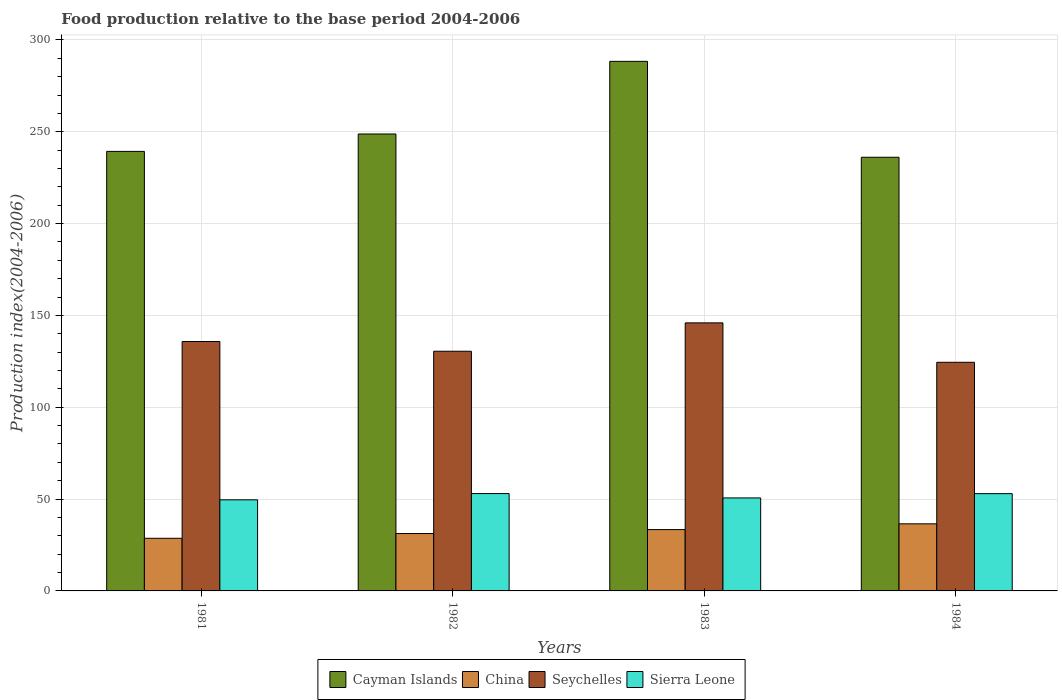How many different coloured bars are there?
Your answer should be very brief. 4. Are the number of bars on each tick of the X-axis equal?
Your answer should be compact. Yes. How many bars are there on the 1st tick from the left?
Offer a terse response. 4. How many bars are there on the 3rd tick from the right?
Give a very brief answer. 4. What is the food production index in Sierra Leone in 1983?
Provide a short and direct response. 50.63. Across all years, what is the maximum food production index in China?
Your answer should be compact. 36.53. Across all years, what is the minimum food production index in Seychelles?
Provide a short and direct response. 124.49. In which year was the food production index in China maximum?
Provide a short and direct response. 1984. What is the total food production index in Seychelles in the graph?
Provide a succinct answer. 536.74. What is the difference between the food production index in China in 1983 and that in 1984?
Provide a short and direct response. -3.13. What is the difference between the food production index in Sierra Leone in 1981 and the food production index in Cayman Islands in 1982?
Offer a very short reply. -199.2. What is the average food production index in Cayman Islands per year?
Keep it short and to the point. 253.15. In the year 1982, what is the difference between the food production index in Cayman Islands and food production index in Sierra Leone?
Make the answer very short. 195.79. In how many years, is the food production index in Sierra Leone greater than 80?
Offer a terse response. 0. What is the ratio of the food production index in Cayman Islands in 1983 to that in 1984?
Your response must be concise. 1.22. Is the food production index in Seychelles in 1981 less than that in 1982?
Make the answer very short. No. Is the difference between the food production index in Cayman Islands in 1981 and 1984 greater than the difference between the food production index in Sierra Leone in 1981 and 1984?
Give a very brief answer. Yes. What is the difference between the highest and the second highest food production index in China?
Make the answer very short. 3.13. What is the difference between the highest and the lowest food production index in China?
Offer a very short reply. 7.87. In how many years, is the food production index in China greater than the average food production index in China taken over all years?
Keep it short and to the point. 2. What does the 1st bar from the left in 1983 represents?
Provide a short and direct response. Cayman Islands. What does the 4th bar from the right in 1982 represents?
Your response must be concise. Cayman Islands. Is it the case that in every year, the sum of the food production index in Cayman Islands and food production index in Sierra Leone is greater than the food production index in Seychelles?
Provide a succinct answer. Yes. How many bars are there?
Offer a very short reply. 16. Does the graph contain any zero values?
Keep it short and to the point. No. Does the graph contain grids?
Provide a short and direct response. Yes. Where does the legend appear in the graph?
Your answer should be very brief. Bottom center. What is the title of the graph?
Provide a succinct answer. Food production relative to the base period 2004-2006. What is the label or title of the X-axis?
Provide a succinct answer. Years. What is the label or title of the Y-axis?
Keep it short and to the point. Production index(2004-2006). What is the Production index(2004-2006) of Cayman Islands in 1981?
Your answer should be compact. 239.32. What is the Production index(2004-2006) in China in 1981?
Make the answer very short. 28.66. What is the Production index(2004-2006) in Seychelles in 1981?
Provide a succinct answer. 135.8. What is the Production index(2004-2006) in Sierra Leone in 1981?
Ensure brevity in your answer.  49.6. What is the Production index(2004-2006) of Cayman Islands in 1982?
Give a very brief answer. 248.8. What is the Production index(2004-2006) of China in 1982?
Provide a short and direct response. 31.24. What is the Production index(2004-2006) of Seychelles in 1982?
Your answer should be very brief. 130.5. What is the Production index(2004-2006) of Sierra Leone in 1982?
Ensure brevity in your answer.  53.01. What is the Production index(2004-2006) in Cayman Islands in 1983?
Your answer should be very brief. 288.34. What is the Production index(2004-2006) of China in 1983?
Offer a terse response. 33.4. What is the Production index(2004-2006) in Seychelles in 1983?
Make the answer very short. 145.95. What is the Production index(2004-2006) of Sierra Leone in 1983?
Provide a short and direct response. 50.63. What is the Production index(2004-2006) of Cayman Islands in 1984?
Offer a terse response. 236.12. What is the Production index(2004-2006) of China in 1984?
Your response must be concise. 36.53. What is the Production index(2004-2006) in Seychelles in 1984?
Your answer should be very brief. 124.49. What is the Production index(2004-2006) in Sierra Leone in 1984?
Provide a succinct answer. 52.96. Across all years, what is the maximum Production index(2004-2006) in Cayman Islands?
Your answer should be very brief. 288.34. Across all years, what is the maximum Production index(2004-2006) of China?
Ensure brevity in your answer.  36.53. Across all years, what is the maximum Production index(2004-2006) in Seychelles?
Ensure brevity in your answer.  145.95. Across all years, what is the maximum Production index(2004-2006) in Sierra Leone?
Ensure brevity in your answer.  53.01. Across all years, what is the minimum Production index(2004-2006) in Cayman Islands?
Give a very brief answer. 236.12. Across all years, what is the minimum Production index(2004-2006) of China?
Provide a short and direct response. 28.66. Across all years, what is the minimum Production index(2004-2006) of Seychelles?
Your answer should be very brief. 124.49. Across all years, what is the minimum Production index(2004-2006) in Sierra Leone?
Make the answer very short. 49.6. What is the total Production index(2004-2006) in Cayman Islands in the graph?
Your answer should be very brief. 1012.58. What is the total Production index(2004-2006) of China in the graph?
Keep it short and to the point. 129.83. What is the total Production index(2004-2006) of Seychelles in the graph?
Your response must be concise. 536.74. What is the total Production index(2004-2006) in Sierra Leone in the graph?
Keep it short and to the point. 206.2. What is the difference between the Production index(2004-2006) of Cayman Islands in 1981 and that in 1982?
Your response must be concise. -9.48. What is the difference between the Production index(2004-2006) in China in 1981 and that in 1982?
Provide a succinct answer. -2.58. What is the difference between the Production index(2004-2006) of Sierra Leone in 1981 and that in 1982?
Give a very brief answer. -3.41. What is the difference between the Production index(2004-2006) of Cayman Islands in 1981 and that in 1983?
Your response must be concise. -49.02. What is the difference between the Production index(2004-2006) of China in 1981 and that in 1983?
Keep it short and to the point. -4.74. What is the difference between the Production index(2004-2006) of Seychelles in 1981 and that in 1983?
Offer a very short reply. -10.15. What is the difference between the Production index(2004-2006) of Sierra Leone in 1981 and that in 1983?
Offer a terse response. -1.03. What is the difference between the Production index(2004-2006) in China in 1981 and that in 1984?
Provide a succinct answer. -7.87. What is the difference between the Production index(2004-2006) of Seychelles in 1981 and that in 1984?
Offer a very short reply. 11.31. What is the difference between the Production index(2004-2006) in Sierra Leone in 1981 and that in 1984?
Your answer should be compact. -3.36. What is the difference between the Production index(2004-2006) of Cayman Islands in 1982 and that in 1983?
Give a very brief answer. -39.54. What is the difference between the Production index(2004-2006) in China in 1982 and that in 1983?
Offer a very short reply. -2.16. What is the difference between the Production index(2004-2006) in Seychelles in 1982 and that in 1983?
Offer a terse response. -15.45. What is the difference between the Production index(2004-2006) of Sierra Leone in 1982 and that in 1983?
Offer a terse response. 2.38. What is the difference between the Production index(2004-2006) of Cayman Islands in 1982 and that in 1984?
Your answer should be very brief. 12.68. What is the difference between the Production index(2004-2006) of China in 1982 and that in 1984?
Make the answer very short. -5.29. What is the difference between the Production index(2004-2006) in Seychelles in 1982 and that in 1984?
Your response must be concise. 6.01. What is the difference between the Production index(2004-2006) in Sierra Leone in 1982 and that in 1984?
Make the answer very short. 0.05. What is the difference between the Production index(2004-2006) in Cayman Islands in 1983 and that in 1984?
Offer a very short reply. 52.22. What is the difference between the Production index(2004-2006) of China in 1983 and that in 1984?
Your response must be concise. -3.13. What is the difference between the Production index(2004-2006) in Seychelles in 1983 and that in 1984?
Your answer should be very brief. 21.46. What is the difference between the Production index(2004-2006) of Sierra Leone in 1983 and that in 1984?
Give a very brief answer. -2.33. What is the difference between the Production index(2004-2006) of Cayman Islands in 1981 and the Production index(2004-2006) of China in 1982?
Your answer should be very brief. 208.08. What is the difference between the Production index(2004-2006) of Cayman Islands in 1981 and the Production index(2004-2006) of Seychelles in 1982?
Provide a succinct answer. 108.82. What is the difference between the Production index(2004-2006) of Cayman Islands in 1981 and the Production index(2004-2006) of Sierra Leone in 1982?
Provide a short and direct response. 186.31. What is the difference between the Production index(2004-2006) in China in 1981 and the Production index(2004-2006) in Seychelles in 1982?
Keep it short and to the point. -101.84. What is the difference between the Production index(2004-2006) in China in 1981 and the Production index(2004-2006) in Sierra Leone in 1982?
Make the answer very short. -24.35. What is the difference between the Production index(2004-2006) in Seychelles in 1981 and the Production index(2004-2006) in Sierra Leone in 1982?
Your response must be concise. 82.79. What is the difference between the Production index(2004-2006) of Cayman Islands in 1981 and the Production index(2004-2006) of China in 1983?
Provide a succinct answer. 205.92. What is the difference between the Production index(2004-2006) of Cayman Islands in 1981 and the Production index(2004-2006) of Seychelles in 1983?
Make the answer very short. 93.37. What is the difference between the Production index(2004-2006) in Cayman Islands in 1981 and the Production index(2004-2006) in Sierra Leone in 1983?
Your answer should be very brief. 188.69. What is the difference between the Production index(2004-2006) in China in 1981 and the Production index(2004-2006) in Seychelles in 1983?
Give a very brief answer. -117.29. What is the difference between the Production index(2004-2006) of China in 1981 and the Production index(2004-2006) of Sierra Leone in 1983?
Provide a succinct answer. -21.97. What is the difference between the Production index(2004-2006) of Seychelles in 1981 and the Production index(2004-2006) of Sierra Leone in 1983?
Keep it short and to the point. 85.17. What is the difference between the Production index(2004-2006) in Cayman Islands in 1981 and the Production index(2004-2006) in China in 1984?
Your answer should be very brief. 202.79. What is the difference between the Production index(2004-2006) in Cayman Islands in 1981 and the Production index(2004-2006) in Seychelles in 1984?
Offer a terse response. 114.83. What is the difference between the Production index(2004-2006) in Cayman Islands in 1981 and the Production index(2004-2006) in Sierra Leone in 1984?
Your answer should be compact. 186.36. What is the difference between the Production index(2004-2006) in China in 1981 and the Production index(2004-2006) in Seychelles in 1984?
Your response must be concise. -95.83. What is the difference between the Production index(2004-2006) of China in 1981 and the Production index(2004-2006) of Sierra Leone in 1984?
Provide a succinct answer. -24.3. What is the difference between the Production index(2004-2006) of Seychelles in 1981 and the Production index(2004-2006) of Sierra Leone in 1984?
Provide a succinct answer. 82.84. What is the difference between the Production index(2004-2006) of Cayman Islands in 1982 and the Production index(2004-2006) of China in 1983?
Give a very brief answer. 215.4. What is the difference between the Production index(2004-2006) in Cayman Islands in 1982 and the Production index(2004-2006) in Seychelles in 1983?
Your response must be concise. 102.85. What is the difference between the Production index(2004-2006) in Cayman Islands in 1982 and the Production index(2004-2006) in Sierra Leone in 1983?
Keep it short and to the point. 198.17. What is the difference between the Production index(2004-2006) of China in 1982 and the Production index(2004-2006) of Seychelles in 1983?
Your response must be concise. -114.71. What is the difference between the Production index(2004-2006) in China in 1982 and the Production index(2004-2006) in Sierra Leone in 1983?
Keep it short and to the point. -19.39. What is the difference between the Production index(2004-2006) in Seychelles in 1982 and the Production index(2004-2006) in Sierra Leone in 1983?
Offer a very short reply. 79.87. What is the difference between the Production index(2004-2006) in Cayman Islands in 1982 and the Production index(2004-2006) in China in 1984?
Provide a succinct answer. 212.27. What is the difference between the Production index(2004-2006) in Cayman Islands in 1982 and the Production index(2004-2006) in Seychelles in 1984?
Your answer should be compact. 124.31. What is the difference between the Production index(2004-2006) of Cayman Islands in 1982 and the Production index(2004-2006) of Sierra Leone in 1984?
Offer a terse response. 195.84. What is the difference between the Production index(2004-2006) of China in 1982 and the Production index(2004-2006) of Seychelles in 1984?
Offer a terse response. -93.25. What is the difference between the Production index(2004-2006) in China in 1982 and the Production index(2004-2006) in Sierra Leone in 1984?
Your answer should be very brief. -21.72. What is the difference between the Production index(2004-2006) of Seychelles in 1982 and the Production index(2004-2006) of Sierra Leone in 1984?
Keep it short and to the point. 77.54. What is the difference between the Production index(2004-2006) in Cayman Islands in 1983 and the Production index(2004-2006) in China in 1984?
Your answer should be very brief. 251.81. What is the difference between the Production index(2004-2006) in Cayman Islands in 1983 and the Production index(2004-2006) in Seychelles in 1984?
Offer a very short reply. 163.85. What is the difference between the Production index(2004-2006) in Cayman Islands in 1983 and the Production index(2004-2006) in Sierra Leone in 1984?
Your answer should be very brief. 235.38. What is the difference between the Production index(2004-2006) of China in 1983 and the Production index(2004-2006) of Seychelles in 1984?
Ensure brevity in your answer.  -91.09. What is the difference between the Production index(2004-2006) in China in 1983 and the Production index(2004-2006) in Sierra Leone in 1984?
Provide a short and direct response. -19.56. What is the difference between the Production index(2004-2006) of Seychelles in 1983 and the Production index(2004-2006) of Sierra Leone in 1984?
Make the answer very short. 92.99. What is the average Production index(2004-2006) in Cayman Islands per year?
Offer a very short reply. 253.15. What is the average Production index(2004-2006) of China per year?
Your answer should be compact. 32.46. What is the average Production index(2004-2006) of Seychelles per year?
Give a very brief answer. 134.19. What is the average Production index(2004-2006) of Sierra Leone per year?
Your answer should be compact. 51.55. In the year 1981, what is the difference between the Production index(2004-2006) in Cayman Islands and Production index(2004-2006) in China?
Make the answer very short. 210.66. In the year 1981, what is the difference between the Production index(2004-2006) in Cayman Islands and Production index(2004-2006) in Seychelles?
Ensure brevity in your answer.  103.52. In the year 1981, what is the difference between the Production index(2004-2006) in Cayman Islands and Production index(2004-2006) in Sierra Leone?
Give a very brief answer. 189.72. In the year 1981, what is the difference between the Production index(2004-2006) of China and Production index(2004-2006) of Seychelles?
Offer a very short reply. -107.14. In the year 1981, what is the difference between the Production index(2004-2006) in China and Production index(2004-2006) in Sierra Leone?
Offer a very short reply. -20.94. In the year 1981, what is the difference between the Production index(2004-2006) of Seychelles and Production index(2004-2006) of Sierra Leone?
Offer a very short reply. 86.2. In the year 1982, what is the difference between the Production index(2004-2006) in Cayman Islands and Production index(2004-2006) in China?
Offer a very short reply. 217.56. In the year 1982, what is the difference between the Production index(2004-2006) of Cayman Islands and Production index(2004-2006) of Seychelles?
Give a very brief answer. 118.3. In the year 1982, what is the difference between the Production index(2004-2006) of Cayman Islands and Production index(2004-2006) of Sierra Leone?
Your response must be concise. 195.79. In the year 1982, what is the difference between the Production index(2004-2006) of China and Production index(2004-2006) of Seychelles?
Provide a succinct answer. -99.26. In the year 1982, what is the difference between the Production index(2004-2006) in China and Production index(2004-2006) in Sierra Leone?
Provide a succinct answer. -21.77. In the year 1982, what is the difference between the Production index(2004-2006) of Seychelles and Production index(2004-2006) of Sierra Leone?
Your answer should be compact. 77.49. In the year 1983, what is the difference between the Production index(2004-2006) in Cayman Islands and Production index(2004-2006) in China?
Provide a short and direct response. 254.94. In the year 1983, what is the difference between the Production index(2004-2006) in Cayman Islands and Production index(2004-2006) in Seychelles?
Make the answer very short. 142.39. In the year 1983, what is the difference between the Production index(2004-2006) in Cayman Islands and Production index(2004-2006) in Sierra Leone?
Your answer should be very brief. 237.71. In the year 1983, what is the difference between the Production index(2004-2006) of China and Production index(2004-2006) of Seychelles?
Offer a very short reply. -112.55. In the year 1983, what is the difference between the Production index(2004-2006) of China and Production index(2004-2006) of Sierra Leone?
Offer a terse response. -17.23. In the year 1983, what is the difference between the Production index(2004-2006) in Seychelles and Production index(2004-2006) in Sierra Leone?
Your response must be concise. 95.32. In the year 1984, what is the difference between the Production index(2004-2006) in Cayman Islands and Production index(2004-2006) in China?
Give a very brief answer. 199.59. In the year 1984, what is the difference between the Production index(2004-2006) of Cayman Islands and Production index(2004-2006) of Seychelles?
Provide a short and direct response. 111.63. In the year 1984, what is the difference between the Production index(2004-2006) in Cayman Islands and Production index(2004-2006) in Sierra Leone?
Offer a very short reply. 183.16. In the year 1984, what is the difference between the Production index(2004-2006) in China and Production index(2004-2006) in Seychelles?
Your answer should be very brief. -87.96. In the year 1984, what is the difference between the Production index(2004-2006) of China and Production index(2004-2006) of Sierra Leone?
Offer a terse response. -16.43. In the year 1984, what is the difference between the Production index(2004-2006) of Seychelles and Production index(2004-2006) of Sierra Leone?
Your response must be concise. 71.53. What is the ratio of the Production index(2004-2006) of Cayman Islands in 1981 to that in 1982?
Provide a succinct answer. 0.96. What is the ratio of the Production index(2004-2006) of China in 1981 to that in 1982?
Offer a very short reply. 0.92. What is the ratio of the Production index(2004-2006) in Seychelles in 1981 to that in 1982?
Make the answer very short. 1.04. What is the ratio of the Production index(2004-2006) of Sierra Leone in 1981 to that in 1982?
Keep it short and to the point. 0.94. What is the ratio of the Production index(2004-2006) in Cayman Islands in 1981 to that in 1983?
Offer a very short reply. 0.83. What is the ratio of the Production index(2004-2006) in China in 1981 to that in 1983?
Your response must be concise. 0.86. What is the ratio of the Production index(2004-2006) of Seychelles in 1981 to that in 1983?
Keep it short and to the point. 0.93. What is the ratio of the Production index(2004-2006) of Sierra Leone in 1981 to that in 1983?
Provide a succinct answer. 0.98. What is the ratio of the Production index(2004-2006) in Cayman Islands in 1981 to that in 1984?
Give a very brief answer. 1.01. What is the ratio of the Production index(2004-2006) in China in 1981 to that in 1984?
Offer a very short reply. 0.78. What is the ratio of the Production index(2004-2006) of Sierra Leone in 1981 to that in 1984?
Keep it short and to the point. 0.94. What is the ratio of the Production index(2004-2006) of Cayman Islands in 1982 to that in 1983?
Make the answer very short. 0.86. What is the ratio of the Production index(2004-2006) of China in 1982 to that in 1983?
Your answer should be very brief. 0.94. What is the ratio of the Production index(2004-2006) in Seychelles in 1982 to that in 1983?
Your answer should be very brief. 0.89. What is the ratio of the Production index(2004-2006) in Sierra Leone in 1982 to that in 1983?
Keep it short and to the point. 1.05. What is the ratio of the Production index(2004-2006) of Cayman Islands in 1982 to that in 1984?
Make the answer very short. 1.05. What is the ratio of the Production index(2004-2006) of China in 1982 to that in 1984?
Your answer should be compact. 0.86. What is the ratio of the Production index(2004-2006) of Seychelles in 1982 to that in 1984?
Provide a short and direct response. 1.05. What is the ratio of the Production index(2004-2006) of Sierra Leone in 1982 to that in 1984?
Give a very brief answer. 1. What is the ratio of the Production index(2004-2006) of Cayman Islands in 1983 to that in 1984?
Your answer should be very brief. 1.22. What is the ratio of the Production index(2004-2006) of China in 1983 to that in 1984?
Make the answer very short. 0.91. What is the ratio of the Production index(2004-2006) in Seychelles in 1983 to that in 1984?
Provide a short and direct response. 1.17. What is the ratio of the Production index(2004-2006) of Sierra Leone in 1983 to that in 1984?
Provide a short and direct response. 0.96. What is the difference between the highest and the second highest Production index(2004-2006) of Cayman Islands?
Provide a succinct answer. 39.54. What is the difference between the highest and the second highest Production index(2004-2006) of China?
Make the answer very short. 3.13. What is the difference between the highest and the second highest Production index(2004-2006) in Seychelles?
Keep it short and to the point. 10.15. What is the difference between the highest and the second highest Production index(2004-2006) in Sierra Leone?
Make the answer very short. 0.05. What is the difference between the highest and the lowest Production index(2004-2006) in Cayman Islands?
Your answer should be very brief. 52.22. What is the difference between the highest and the lowest Production index(2004-2006) in China?
Your answer should be very brief. 7.87. What is the difference between the highest and the lowest Production index(2004-2006) of Seychelles?
Keep it short and to the point. 21.46. What is the difference between the highest and the lowest Production index(2004-2006) in Sierra Leone?
Ensure brevity in your answer.  3.41. 